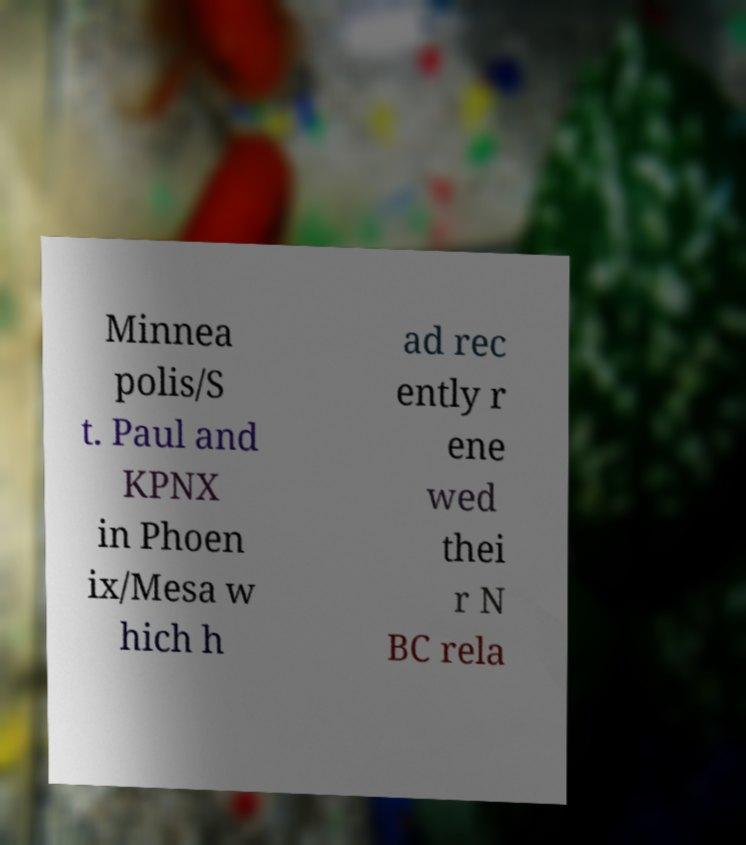Please read and relay the text visible in this image. What does it say? Minnea polis/S t. Paul and KPNX in Phoen ix/Mesa w hich h ad rec ently r ene wed thei r N BC rela 